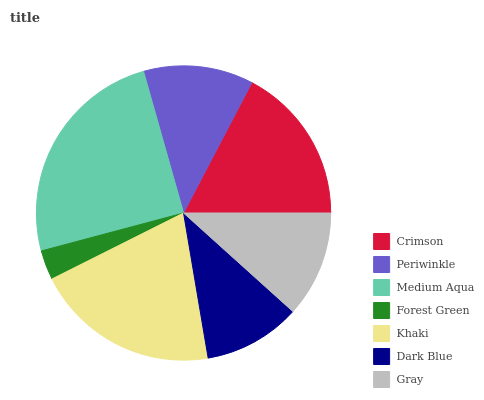Is Forest Green the minimum?
Answer yes or no. Yes. Is Medium Aqua the maximum?
Answer yes or no. Yes. Is Periwinkle the minimum?
Answer yes or no. No. Is Periwinkle the maximum?
Answer yes or no. No. Is Crimson greater than Periwinkle?
Answer yes or no. Yes. Is Periwinkle less than Crimson?
Answer yes or no. Yes. Is Periwinkle greater than Crimson?
Answer yes or no. No. Is Crimson less than Periwinkle?
Answer yes or no. No. Is Periwinkle the high median?
Answer yes or no. Yes. Is Periwinkle the low median?
Answer yes or no. Yes. Is Crimson the high median?
Answer yes or no. No. Is Khaki the low median?
Answer yes or no. No. 